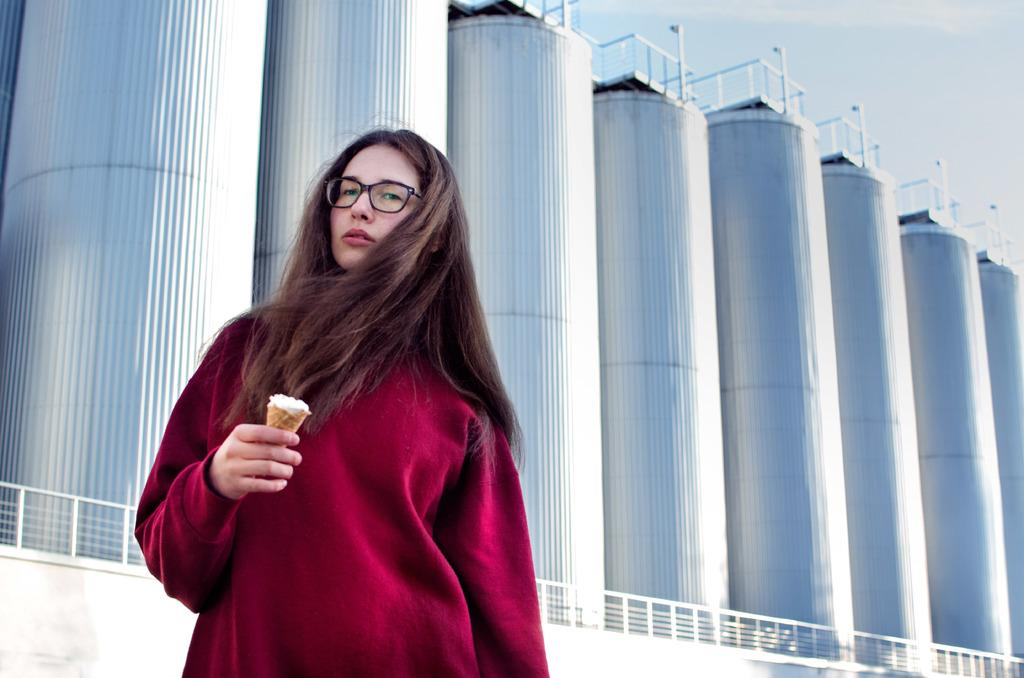What is the person in the image doing? The person is standing in the image. What is the person holding in the image? The person is holding a food item. What can be seen in the background of the image? There is a wall with a fence, machines, poles, and the sky visible in the background. How many eyes does the winged frog have in the image? There is no winged frog present in the image. 